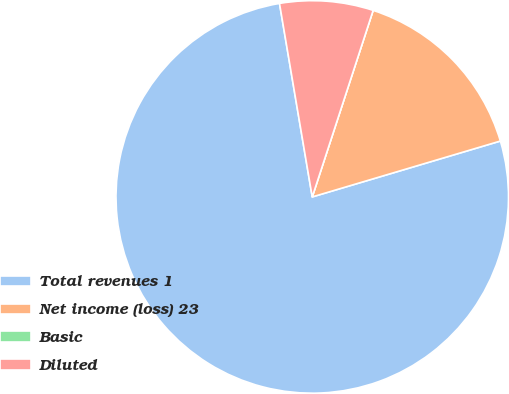<chart> <loc_0><loc_0><loc_500><loc_500><pie_chart><fcel>Total revenues 1<fcel>Net income (loss) 23<fcel>Basic<fcel>Diluted<nl><fcel>76.92%<fcel>15.38%<fcel>0.0%<fcel>7.69%<nl></chart> 